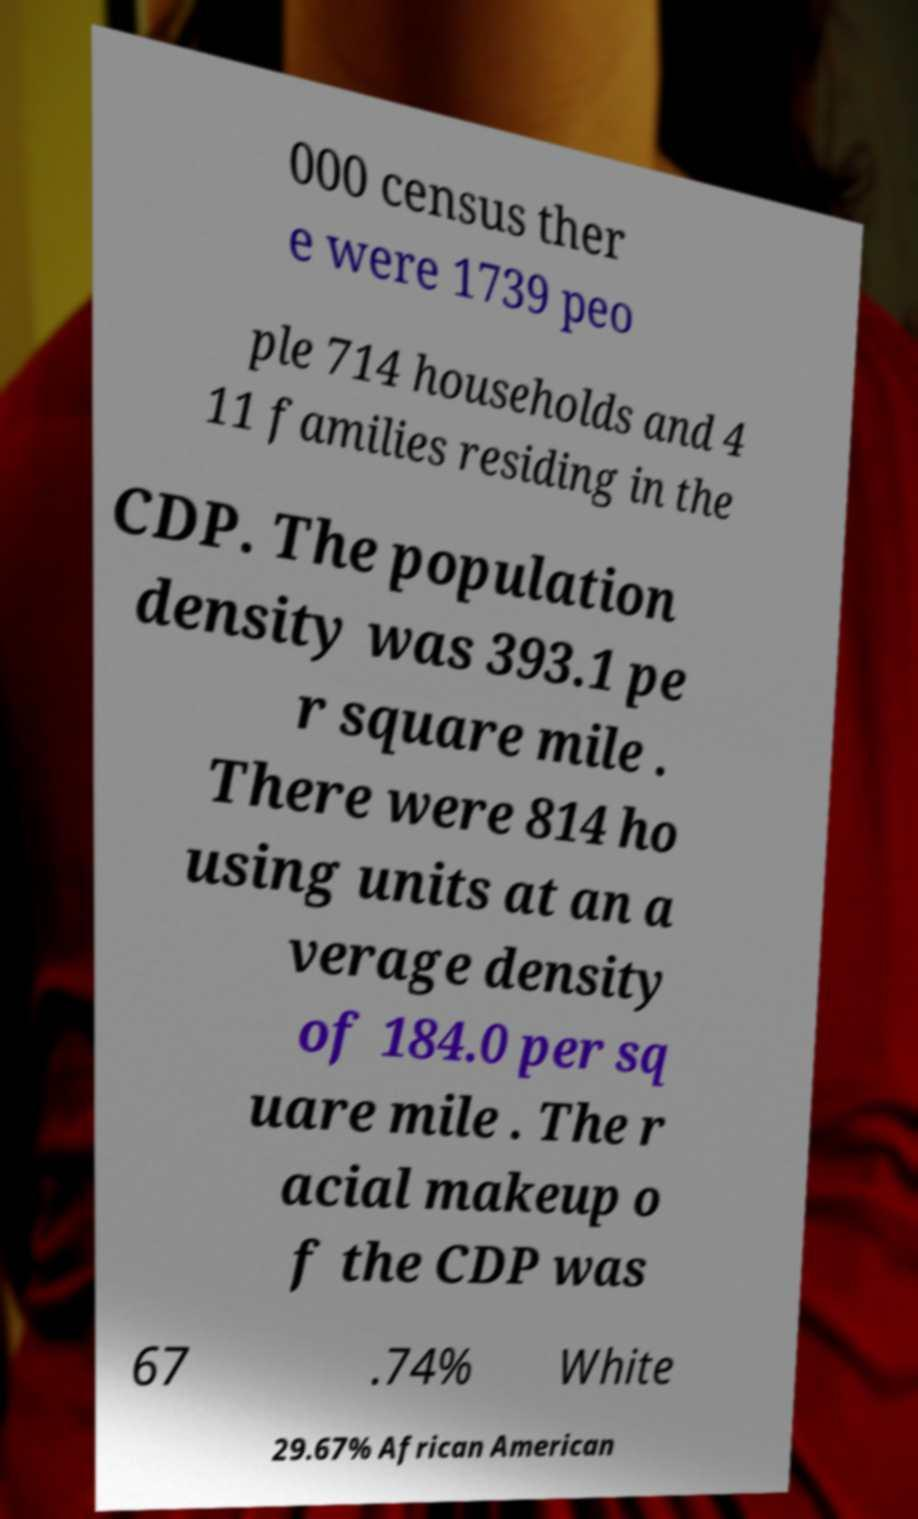There's text embedded in this image that I need extracted. Can you transcribe it verbatim? 000 census ther e were 1739 peo ple 714 households and 4 11 families residing in the CDP. The population density was 393.1 pe r square mile . There were 814 ho using units at an a verage density of 184.0 per sq uare mile . The r acial makeup o f the CDP was 67 .74% White 29.67% African American 